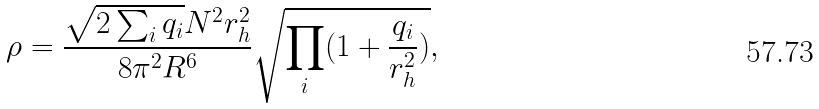<formula> <loc_0><loc_0><loc_500><loc_500>\rho = \frac { \sqrt { 2 \sum _ { i } q _ { i } } N ^ { 2 } r _ { h } ^ { 2 } } { 8 \pi ^ { 2 } R ^ { 6 } } \sqrt { \prod _ { i } ( 1 + \frac { q _ { i } } { r _ { h } ^ { 2 } } ) } ,</formula> 